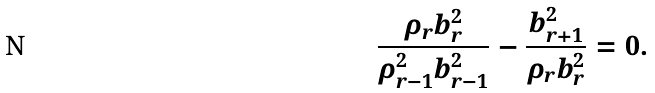Convert formula to latex. <formula><loc_0><loc_0><loc_500><loc_500>\frac { \rho _ { r } b _ { r } ^ { 2 } } { \rho ^ { 2 } _ { r - 1 } b _ { r - 1 } ^ { 2 } } - \frac { b _ { r + 1 } ^ { 2 } } { \rho _ { r } b _ { r } ^ { 2 } } = 0 .</formula> 